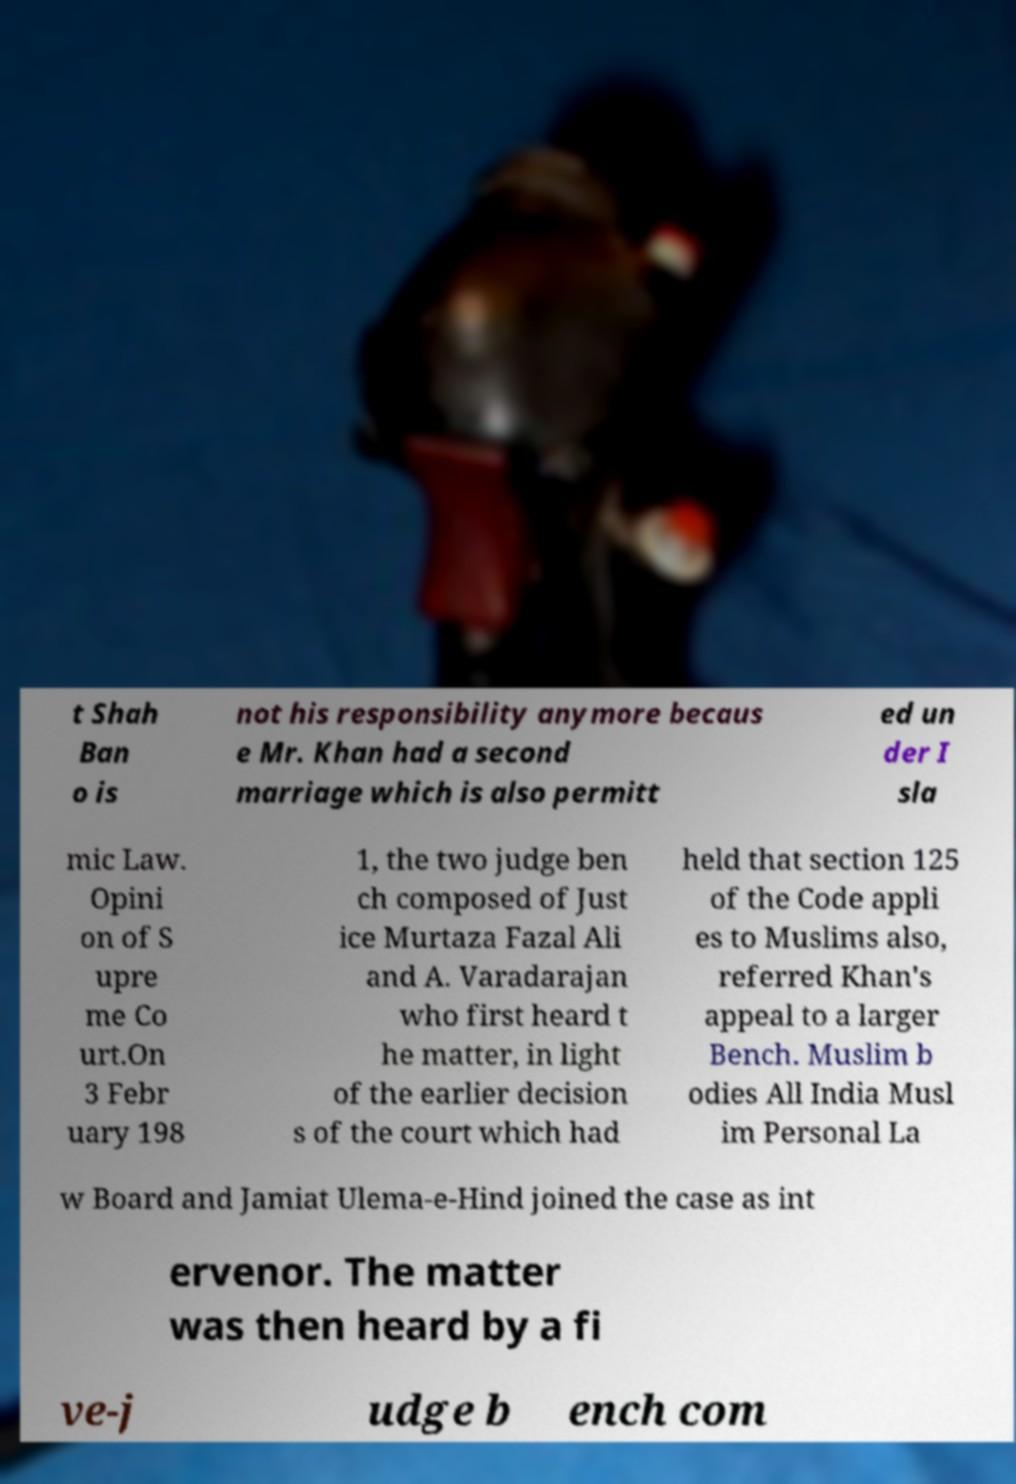Please identify and transcribe the text found in this image. t Shah Ban o is not his responsibility anymore becaus e Mr. Khan had a second marriage which is also permitt ed un der I sla mic Law. Opini on of S upre me Co urt.On 3 Febr uary 198 1, the two judge ben ch composed of Just ice Murtaza Fazal Ali and A. Varadarajan who first heard t he matter, in light of the earlier decision s of the court which had held that section 125 of the Code appli es to Muslims also, referred Khan's appeal to a larger Bench. Muslim b odies All India Musl im Personal La w Board and Jamiat Ulema-e-Hind joined the case as int ervenor. The matter was then heard by a fi ve-j udge b ench com 